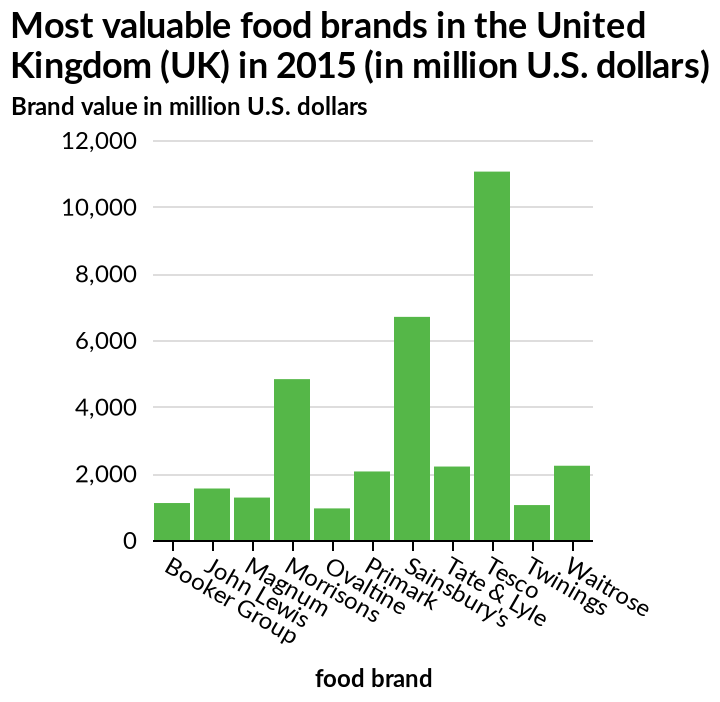<image>
please summary the statistics and relations of the chart The 3 most expensive food brands are supermarkets. What type of stores are the 3 most expensive food brands? Supermarkets. 